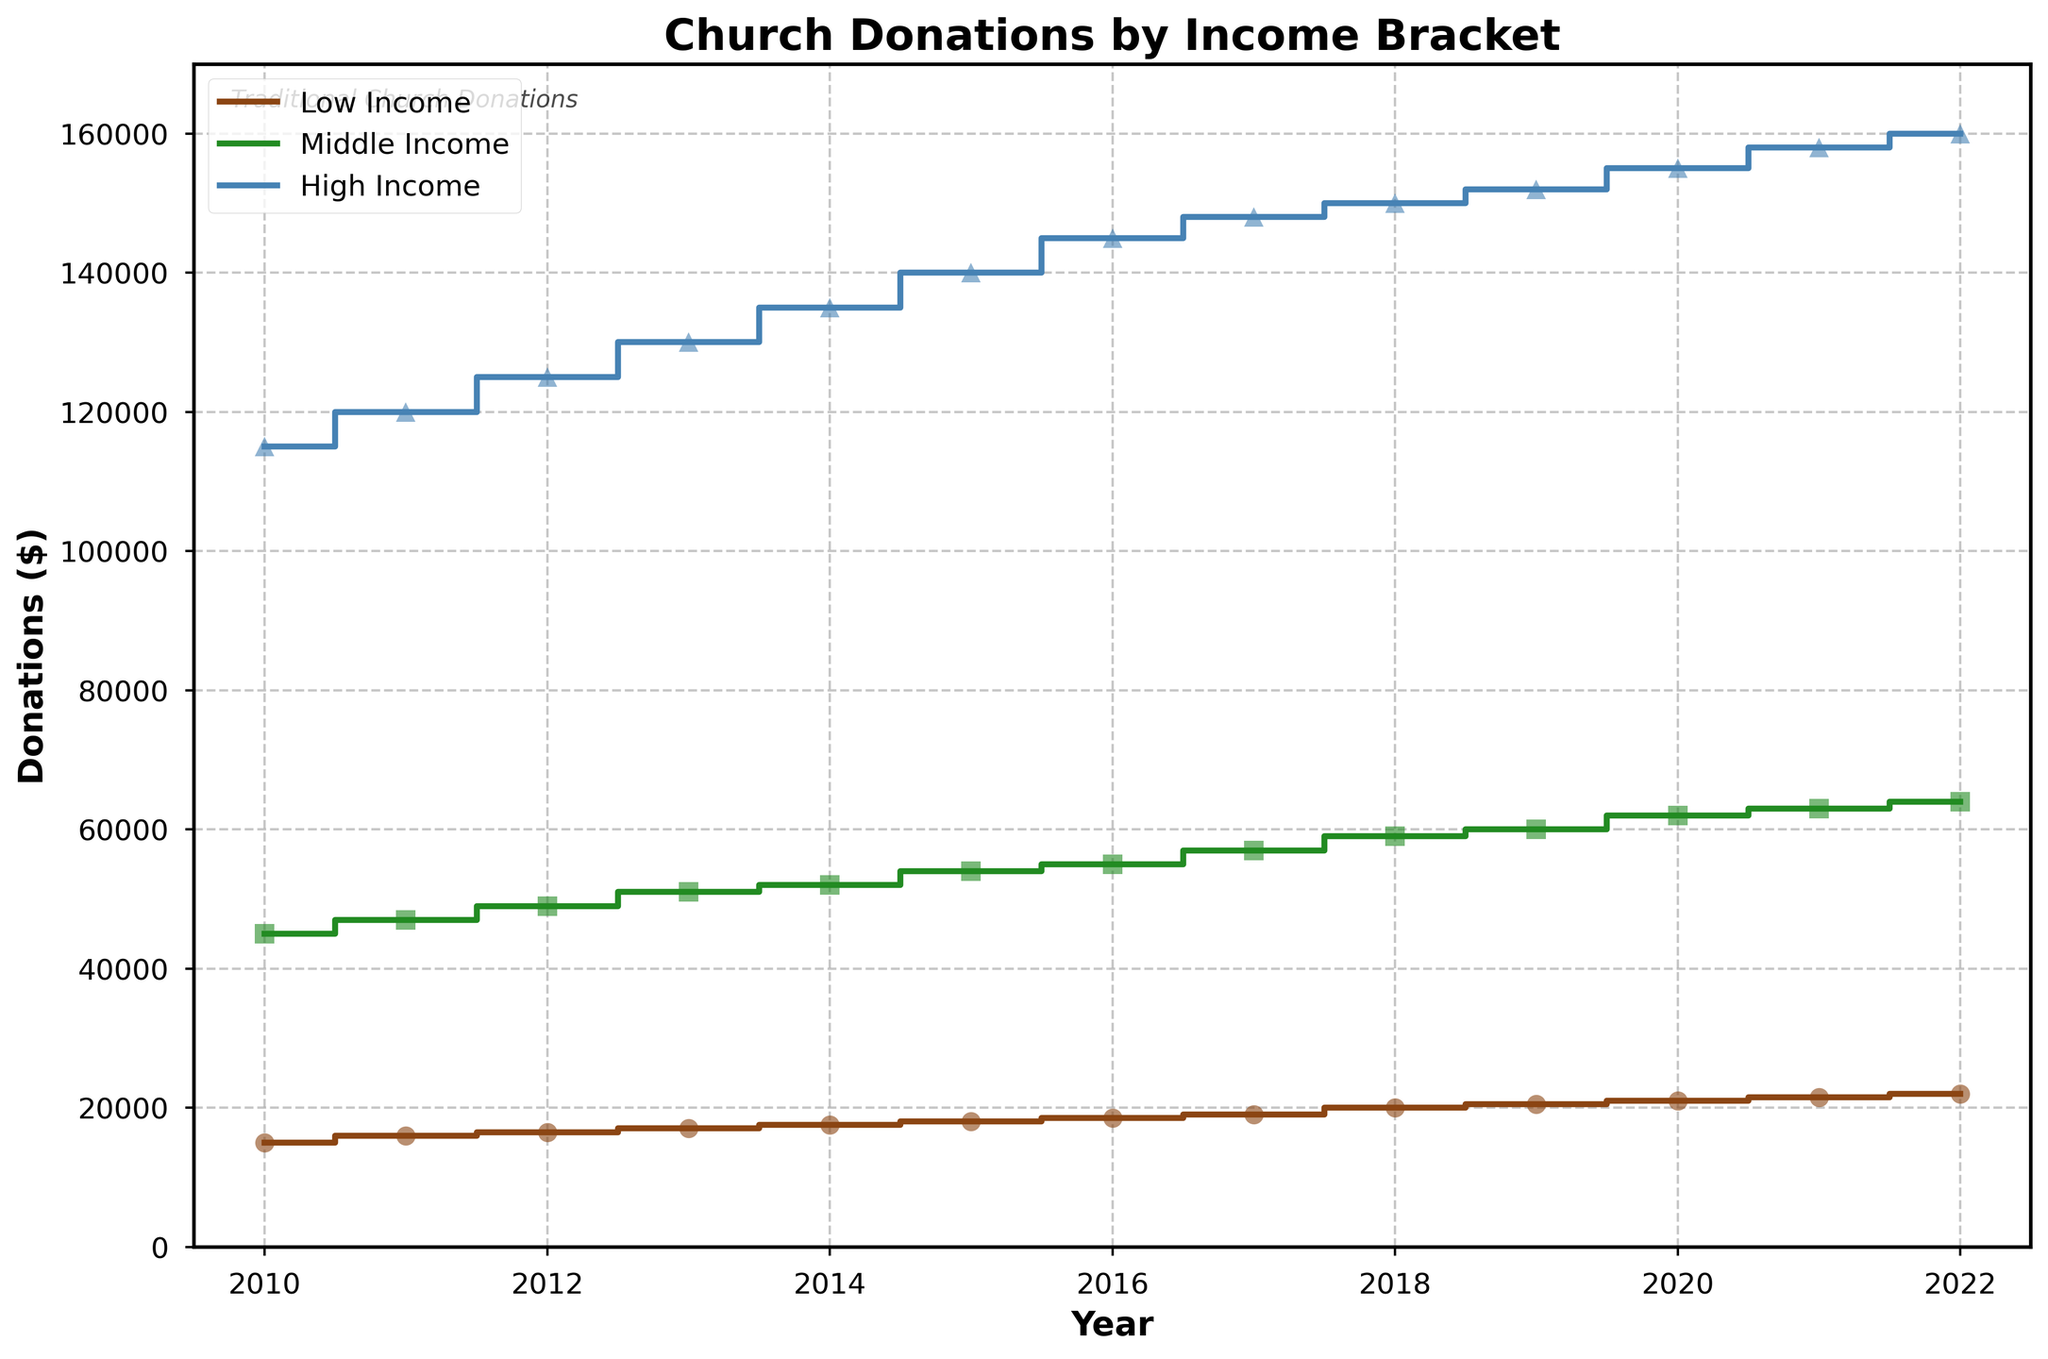What is the title of the plot? The title of the plot is displayed at the top and helps understand the main focus. The specific title in this case is "Church Donations by Income Bracket."
Answer: Church Donations by Income Bracket What does the x-axis represent? The x-axis, labeled "Year," shows the time period from 2010 to 2022. This helps determine the donation trends over these years.
Answer: Year Which color represents the High Income group in the plot? The legend indicates the High Income group is assigned the color blue. By looking at the line colors in the plot, the blue one corresponds to High Income.
Answer: Blue How many distinct income brackets are represented in the plot? By referring to the legend, we see three distinct income brackets: Low Income, Middle Income, and High Income.
Answer: 3 What is the donation amount for the Middle Income group in the year 2015? The Middle Income donations in 2015 can be found by locating the value on the green step line marked with a square for that year. The donation is labeled at $54,000.
Answer: $54,000 Which income group showed the highest increase in donations from 2010 to 2022? By comparing the beginning and ending points of each income group’s line, we can see the Low Income group increased from $15,000 to $22,000, the Middle Income from $45,000 to $64,000, and the High Income from $115,000 to $160,000. Taking the difference, the High Income group shows the highest increase of $45,000.
Answer: High Income Which year shows the smallest difference in donations between the Low Income and Middle Income groups? To find this, we compare the differences for each year. For example, in 2010, the difference is $45,000 - $15,000 = $30,000. Continuing this method, the smallest difference occurs in 2010.
Answer: 2010 What trend can be observed for High Income donations from 2010 to 2022? By examining the blue step line, we observe a consistent upward trend from $115,000 in 2010 to $160,000 in 2022, indicating an increase in donations over the period.
Answer: Consistent increase Is there any year where the donations from all three income brackets are the same? By visually comparing the step lines for all years, we see that no year shows all three lines meeting at a single donation value, indicating donations were different in each year.
Answer: No How much total donation was made in 2022 by the Low Income and Middle Income groups combined? By adding the donations from these groups in 2022: $22,000 (Low Income) + $64,000 (Middle Income) = $86,000.
Answer: $86,000 